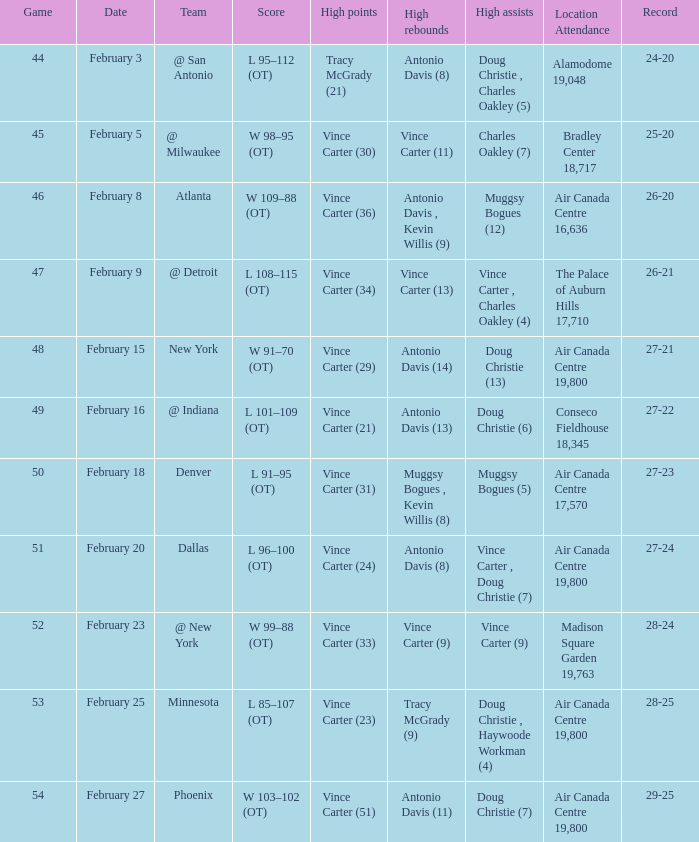Who was the rival team for game 53? Minnesota. 